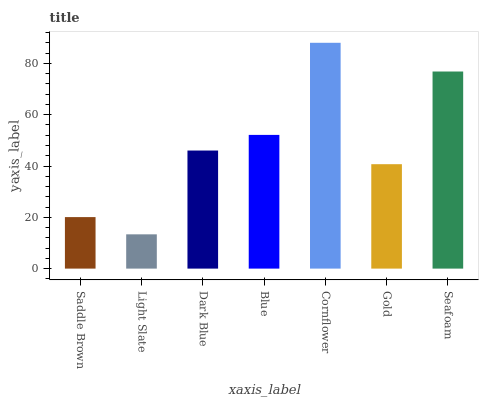Is Light Slate the minimum?
Answer yes or no. Yes. Is Cornflower the maximum?
Answer yes or no. Yes. Is Dark Blue the minimum?
Answer yes or no. No. Is Dark Blue the maximum?
Answer yes or no. No. Is Dark Blue greater than Light Slate?
Answer yes or no. Yes. Is Light Slate less than Dark Blue?
Answer yes or no. Yes. Is Light Slate greater than Dark Blue?
Answer yes or no. No. Is Dark Blue less than Light Slate?
Answer yes or no. No. Is Dark Blue the high median?
Answer yes or no. Yes. Is Dark Blue the low median?
Answer yes or no. Yes. Is Light Slate the high median?
Answer yes or no. No. Is Blue the low median?
Answer yes or no. No. 